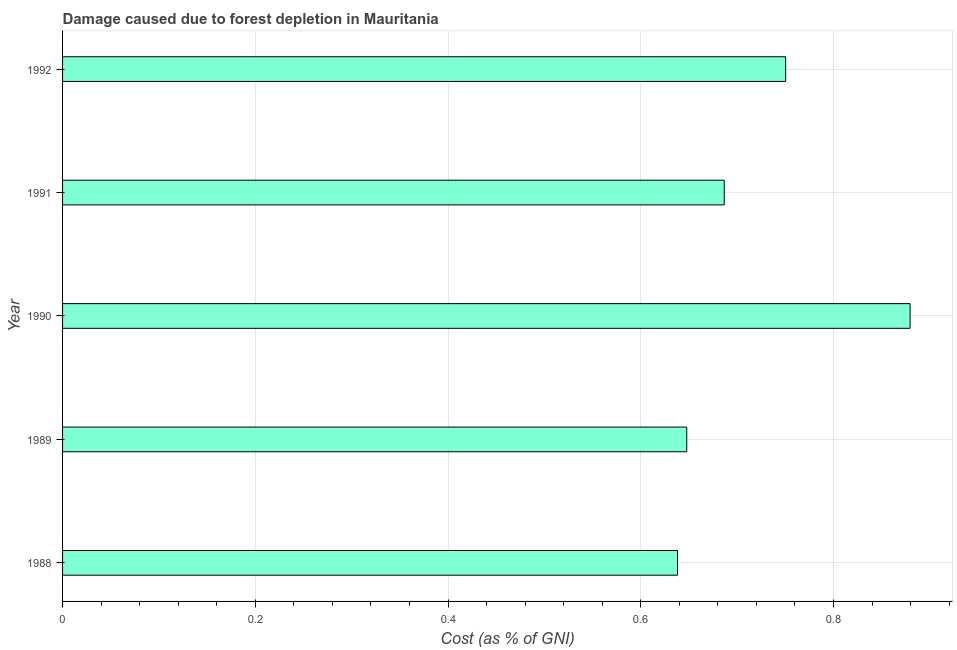What is the title of the graph?
Offer a terse response. Damage caused due to forest depletion in Mauritania. What is the label or title of the X-axis?
Your response must be concise. Cost (as % of GNI). What is the damage caused due to forest depletion in 1990?
Your answer should be very brief. 0.88. Across all years, what is the maximum damage caused due to forest depletion?
Your answer should be very brief. 0.88. Across all years, what is the minimum damage caused due to forest depletion?
Offer a very short reply. 0.64. What is the sum of the damage caused due to forest depletion?
Give a very brief answer. 3.6. What is the difference between the damage caused due to forest depletion in 1989 and 1992?
Your answer should be compact. -0.1. What is the average damage caused due to forest depletion per year?
Give a very brief answer. 0.72. What is the median damage caused due to forest depletion?
Offer a terse response. 0.69. What is the ratio of the damage caused due to forest depletion in 1990 to that in 1991?
Offer a terse response. 1.28. Is the difference between the damage caused due to forest depletion in 1988 and 1992 greater than the difference between any two years?
Your answer should be compact. No. What is the difference between the highest and the second highest damage caused due to forest depletion?
Your answer should be very brief. 0.13. Is the sum of the damage caused due to forest depletion in 1988 and 1990 greater than the maximum damage caused due to forest depletion across all years?
Your answer should be very brief. Yes. What is the difference between the highest and the lowest damage caused due to forest depletion?
Provide a succinct answer. 0.24. How many years are there in the graph?
Give a very brief answer. 5. What is the difference between two consecutive major ticks on the X-axis?
Keep it short and to the point. 0.2. What is the Cost (as % of GNI) in 1988?
Offer a terse response. 0.64. What is the Cost (as % of GNI) in 1989?
Provide a short and direct response. 0.65. What is the Cost (as % of GNI) of 1990?
Keep it short and to the point. 0.88. What is the Cost (as % of GNI) of 1991?
Make the answer very short. 0.69. What is the Cost (as % of GNI) in 1992?
Give a very brief answer. 0.75. What is the difference between the Cost (as % of GNI) in 1988 and 1989?
Offer a very short reply. -0.01. What is the difference between the Cost (as % of GNI) in 1988 and 1990?
Provide a succinct answer. -0.24. What is the difference between the Cost (as % of GNI) in 1988 and 1991?
Provide a short and direct response. -0.05. What is the difference between the Cost (as % of GNI) in 1988 and 1992?
Ensure brevity in your answer.  -0.11. What is the difference between the Cost (as % of GNI) in 1989 and 1990?
Your answer should be very brief. -0.23. What is the difference between the Cost (as % of GNI) in 1989 and 1991?
Your answer should be very brief. -0.04. What is the difference between the Cost (as % of GNI) in 1989 and 1992?
Your answer should be very brief. -0.1. What is the difference between the Cost (as % of GNI) in 1990 and 1991?
Keep it short and to the point. 0.19. What is the difference between the Cost (as % of GNI) in 1990 and 1992?
Offer a very short reply. 0.13. What is the difference between the Cost (as % of GNI) in 1991 and 1992?
Your answer should be very brief. -0.06. What is the ratio of the Cost (as % of GNI) in 1988 to that in 1989?
Your response must be concise. 0.98. What is the ratio of the Cost (as % of GNI) in 1988 to that in 1990?
Make the answer very short. 0.73. What is the ratio of the Cost (as % of GNI) in 1988 to that in 1991?
Provide a succinct answer. 0.93. What is the ratio of the Cost (as % of GNI) in 1989 to that in 1990?
Give a very brief answer. 0.74. What is the ratio of the Cost (as % of GNI) in 1989 to that in 1991?
Give a very brief answer. 0.94. What is the ratio of the Cost (as % of GNI) in 1989 to that in 1992?
Provide a succinct answer. 0.86. What is the ratio of the Cost (as % of GNI) in 1990 to that in 1991?
Keep it short and to the point. 1.28. What is the ratio of the Cost (as % of GNI) in 1990 to that in 1992?
Provide a short and direct response. 1.17. What is the ratio of the Cost (as % of GNI) in 1991 to that in 1992?
Ensure brevity in your answer.  0.92. 